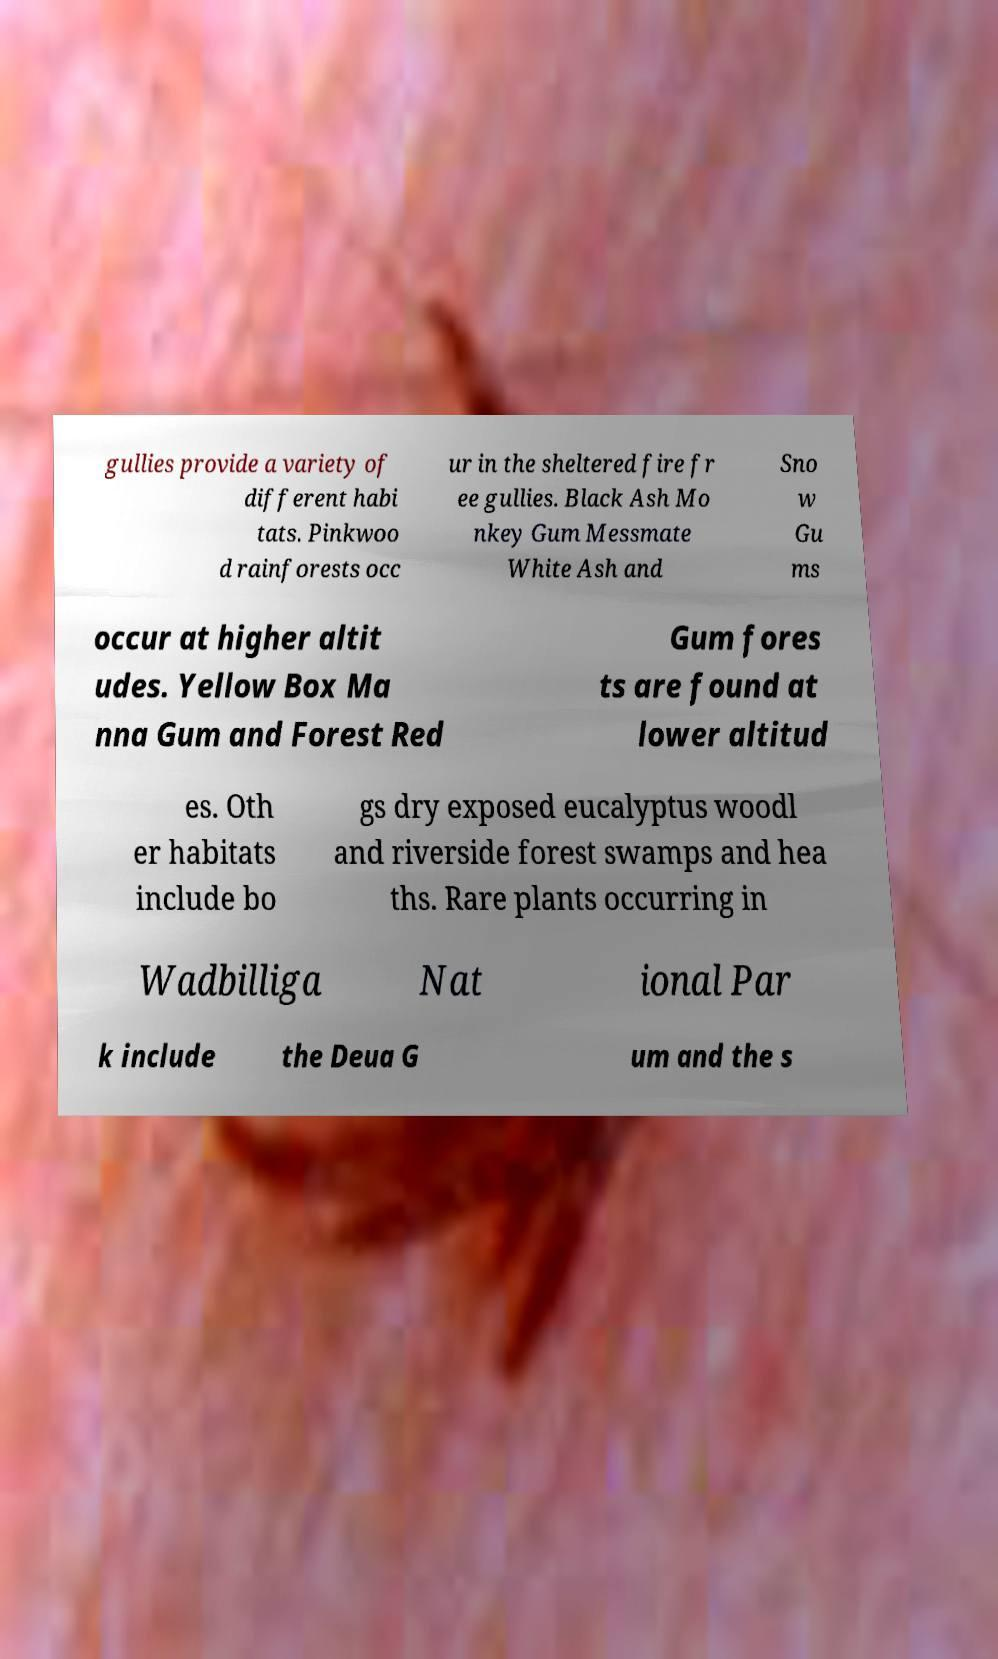Could you extract and type out the text from this image? gullies provide a variety of different habi tats. Pinkwoo d rainforests occ ur in the sheltered fire fr ee gullies. Black Ash Mo nkey Gum Messmate White Ash and Sno w Gu ms occur at higher altit udes. Yellow Box Ma nna Gum and Forest Red Gum fores ts are found at lower altitud es. Oth er habitats include bo gs dry exposed eucalyptus woodl and riverside forest swamps and hea ths. Rare plants occurring in Wadbilliga Nat ional Par k include the Deua G um and the s 